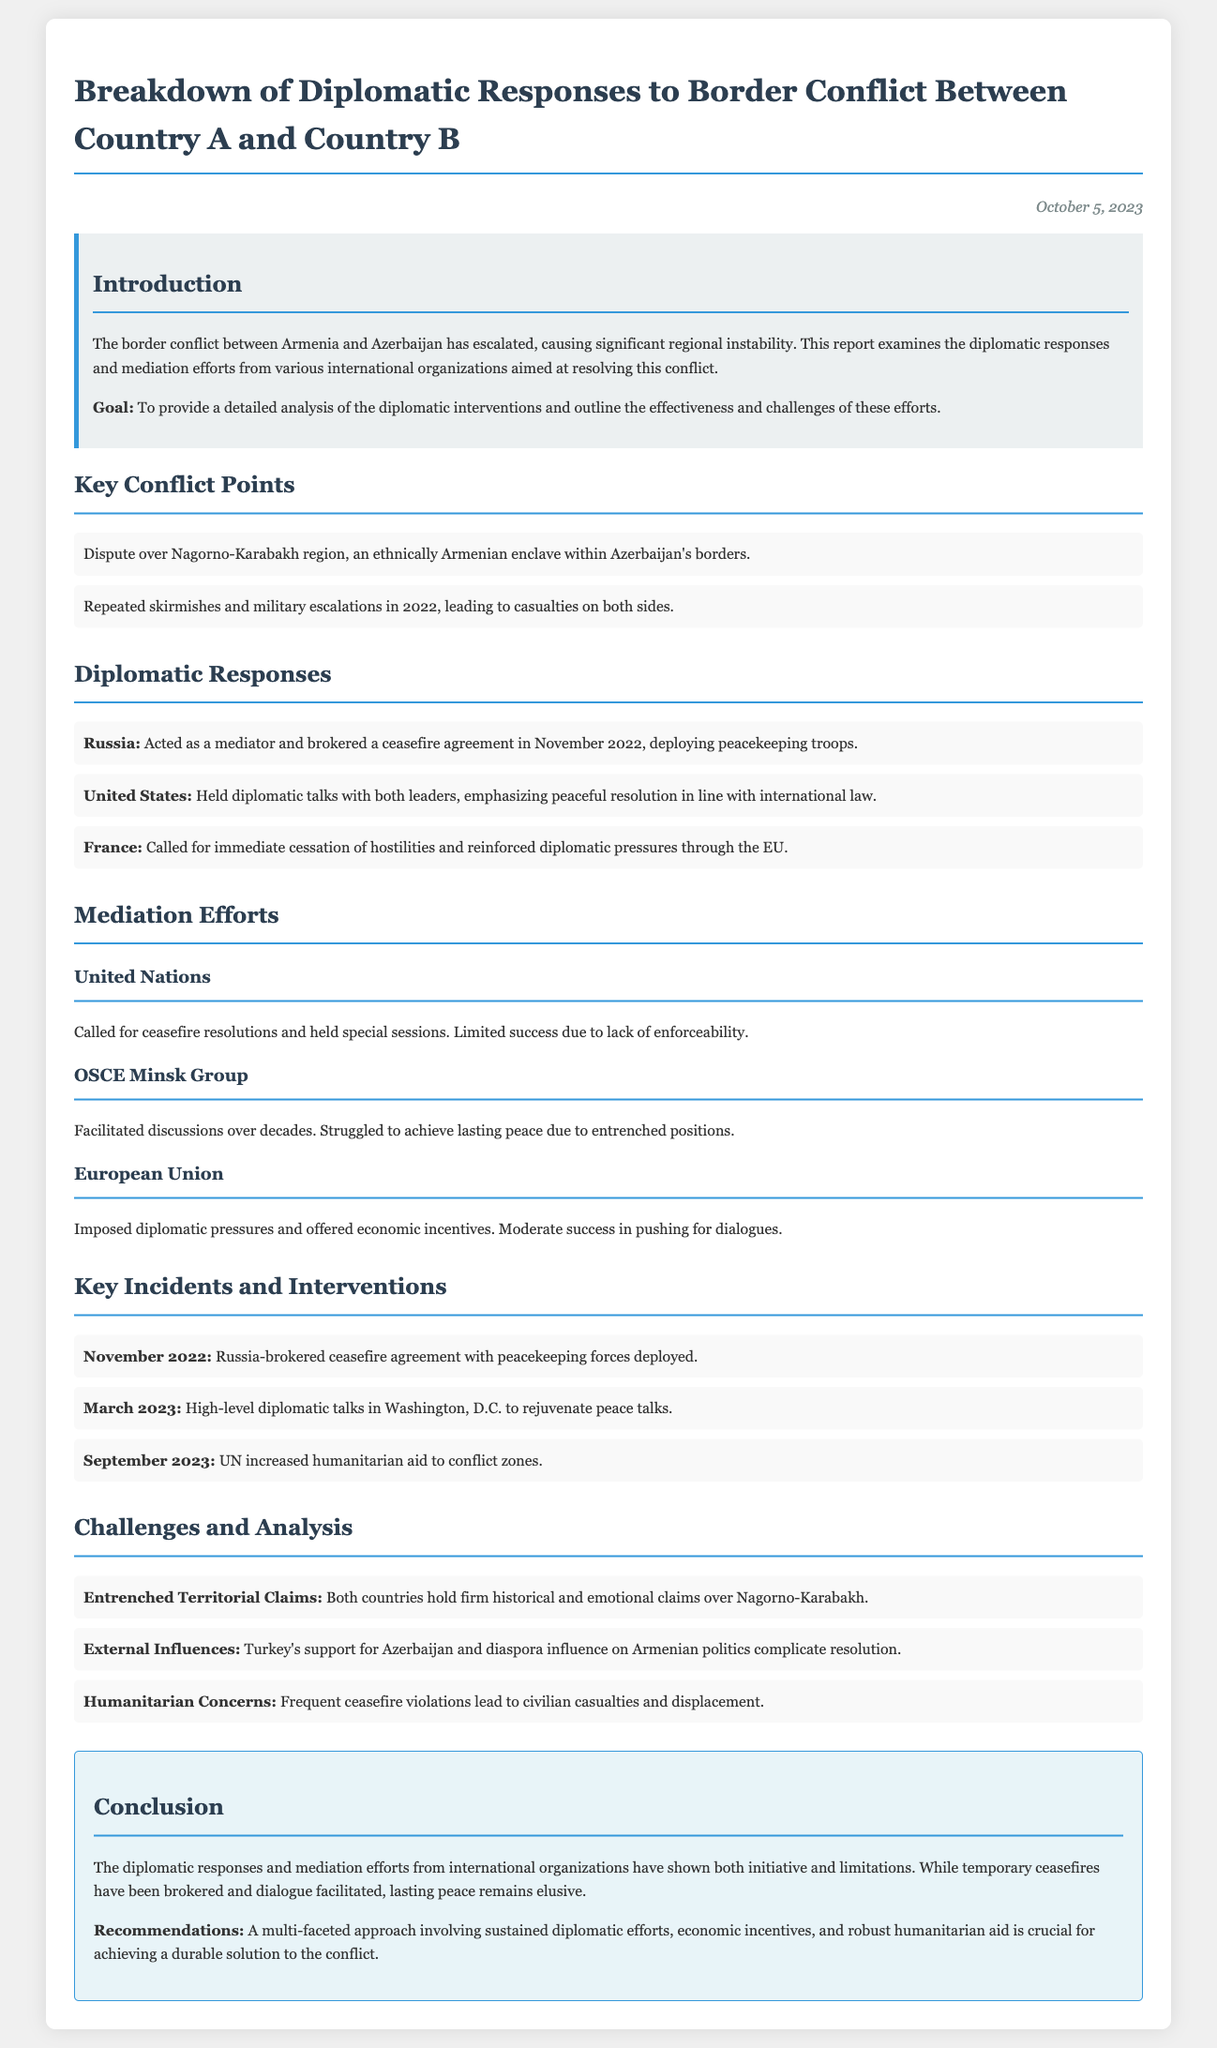What is the date of the report? The date is provided in the header of the document, stating the report was published on October 5, 2023.
Answer: October 5, 2023 Who brokered the ceasefire agreement in November 2022? The diplomatic response section mentions that Russia acted as a mediator and brokered the ceasefire agreement.
Answer: Russia What is the main region involved in the border conflict? The introduction highlights the dispute over the Nagorno-Karabakh region, which is central to the conflict.
Answer: Nagorno-Karabakh Which international organization called for ceasefire resolutions? The mediation section states that the United Nations called for ceasefire resolutions during the conflict.
Answer: United Nations What challenges complicate the resolution between Country A and B? The challenges section lists several factors, including entrenched territorial claims, external influences, and humanitarian concerns.
Answer: Entrenched Territorial Claims What was a significant incident in March 2023? The key incidents section provides details of high-level diplomatic talks that took place in Washington, D.C.
Answer: High-level diplomatic talks in Washington, D.C What did the European Union impose to encourage dialogue? The mediation section notes that the European Union imposed diplomatic pressures and offered economic incentives for dialogue.
Answer: Diplomatic pressures and economic incentives How does the report describe the effectiveness of mediation efforts? The concluding section of the document summarizes that mediation efforts showed both initiative and limitations, indicating mixed effectiveness.
Answer: Initiative and limitations What is recommended for achieving a durable solution to the conflict? The conclusion provides recommendations, emphasizing the need for a multi-faceted approach involving sustained diplomatic efforts.
Answer: Sustained diplomatic efforts 